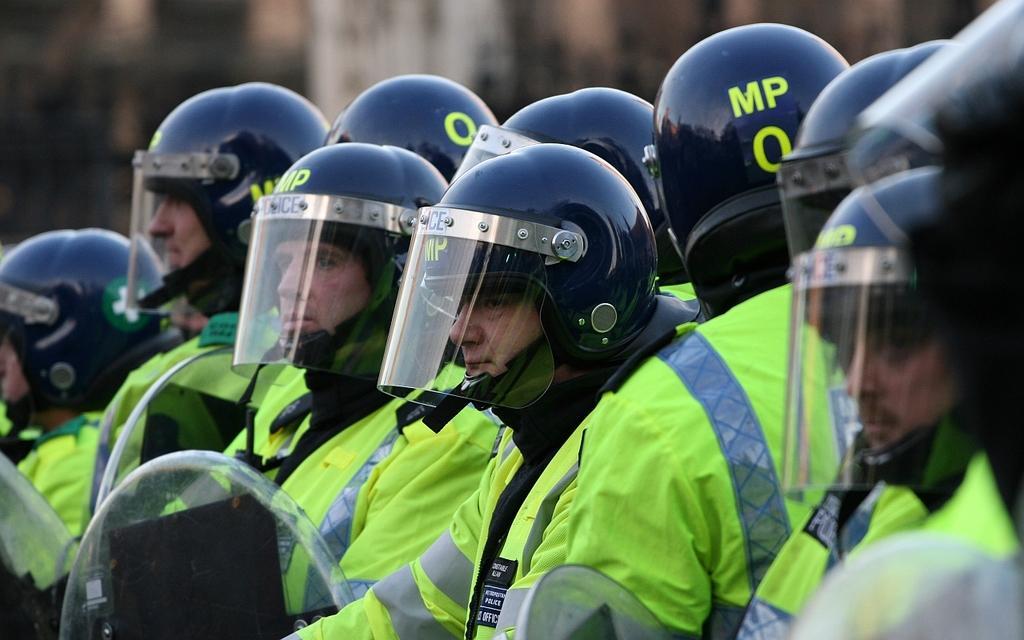In one or two sentences, can you explain what this image depicts? In this picture I can observe some people. Most of them are men. They are wearing green color suits and helmets on their heads. The background is blurred. 